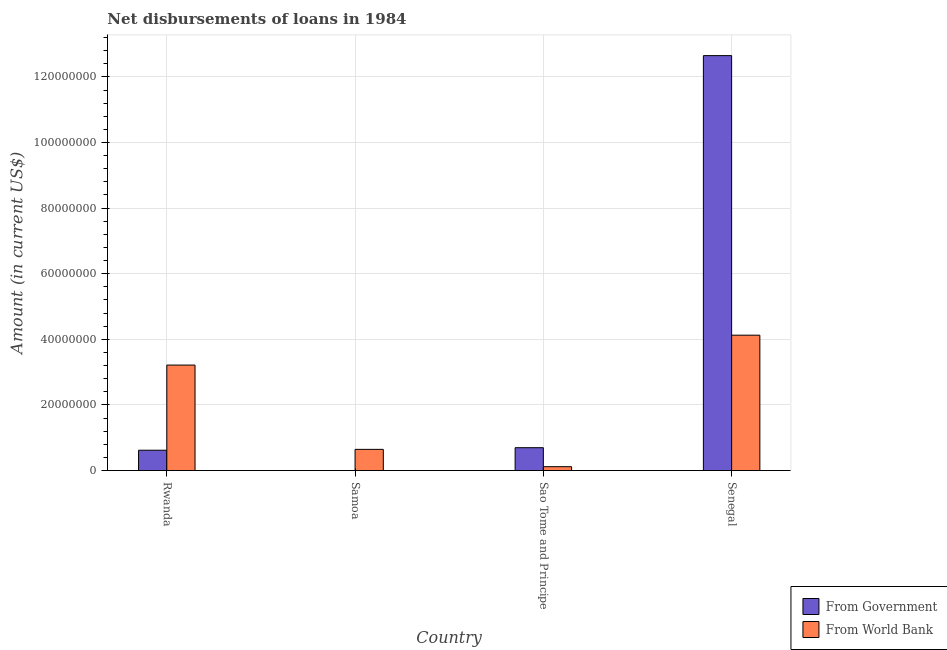How many different coloured bars are there?
Your answer should be compact. 2. Are the number of bars per tick equal to the number of legend labels?
Provide a short and direct response. No. How many bars are there on the 3rd tick from the left?
Make the answer very short. 2. What is the label of the 1st group of bars from the left?
Provide a short and direct response. Rwanda. What is the net disbursements of loan from government in Rwanda?
Provide a short and direct response. 6.20e+06. Across all countries, what is the maximum net disbursements of loan from government?
Give a very brief answer. 1.26e+08. In which country was the net disbursements of loan from government maximum?
Ensure brevity in your answer.  Senegal. What is the total net disbursements of loan from world bank in the graph?
Your response must be concise. 8.11e+07. What is the difference between the net disbursements of loan from government in Rwanda and that in Senegal?
Your answer should be very brief. -1.20e+08. What is the difference between the net disbursements of loan from government in Samoa and the net disbursements of loan from world bank in Rwanda?
Your response must be concise. -3.22e+07. What is the average net disbursements of loan from world bank per country?
Make the answer very short. 2.03e+07. What is the difference between the net disbursements of loan from government and net disbursements of loan from world bank in Rwanda?
Offer a terse response. -2.60e+07. In how many countries, is the net disbursements of loan from government greater than 108000000 US$?
Your answer should be compact. 1. What is the ratio of the net disbursements of loan from government in Rwanda to that in Sao Tome and Principe?
Your answer should be compact. 0.89. What is the difference between the highest and the second highest net disbursements of loan from world bank?
Provide a succinct answer. 9.11e+06. What is the difference between the highest and the lowest net disbursements of loan from world bank?
Offer a terse response. 4.01e+07. In how many countries, is the net disbursements of loan from world bank greater than the average net disbursements of loan from world bank taken over all countries?
Keep it short and to the point. 2. Is the sum of the net disbursements of loan from world bank in Rwanda and Senegal greater than the maximum net disbursements of loan from government across all countries?
Your response must be concise. No. What is the difference between two consecutive major ticks on the Y-axis?
Provide a succinct answer. 2.00e+07. Are the values on the major ticks of Y-axis written in scientific E-notation?
Your answer should be very brief. No. Does the graph contain any zero values?
Make the answer very short. Yes. Does the graph contain grids?
Keep it short and to the point. Yes. How are the legend labels stacked?
Your response must be concise. Vertical. What is the title of the graph?
Offer a very short reply. Net disbursements of loans in 1984. What is the label or title of the X-axis?
Your response must be concise. Country. What is the Amount (in current US$) of From Government in Rwanda?
Your response must be concise. 6.20e+06. What is the Amount (in current US$) in From World Bank in Rwanda?
Provide a short and direct response. 3.22e+07. What is the Amount (in current US$) in From Government in Samoa?
Provide a short and direct response. 0. What is the Amount (in current US$) of From World Bank in Samoa?
Give a very brief answer. 6.46e+06. What is the Amount (in current US$) of From Government in Sao Tome and Principe?
Offer a terse response. 6.97e+06. What is the Amount (in current US$) in From World Bank in Sao Tome and Principe?
Provide a short and direct response. 1.19e+06. What is the Amount (in current US$) of From Government in Senegal?
Provide a short and direct response. 1.26e+08. What is the Amount (in current US$) of From World Bank in Senegal?
Provide a short and direct response. 4.13e+07. Across all countries, what is the maximum Amount (in current US$) in From Government?
Your response must be concise. 1.26e+08. Across all countries, what is the maximum Amount (in current US$) of From World Bank?
Ensure brevity in your answer.  4.13e+07. Across all countries, what is the minimum Amount (in current US$) in From World Bank?
Give a very brief answer. 1.19e+06. What is the total Amount (in current US$) of From Government in the graph?
Your response must be concise. 1.40e+08. What is the total Amount (in current US$) in From World Bank in the graph?
Offer a terse response. 8.11e+07. What is the difference between the Amount (in current US$) in From World Bank in Rwanda and that in Samoa?
Ensure brevity in your answer.  2.57e+07. What is the difference between the Amount (in current US$) of From Government in Rwanda and that in Sao Tome and Principe?
Keep it short and to the point. -7.71e+05. What is the difference between the Amount (in current US$) in From World Bank in Rwanda and that in Sao Tome and Principe?
Your answer should be compact. 3.10e+07. What is the difference between the Amount (in current US$) of From Government in Rwanda and that in Senegal?
Make the answer very short. -1.20e+08. What is the difference between the Amount (in current US$) of From World Bank in Rwanda and that in Senegal?
Provide a short and direct response. -9.11e+06. What is the difference between the Amount (in current US$) of From World Bank in Samoa and that in Sao Tome and Principe?
Make the answer very short. 5.28e+06. What is the difference between the Amount (in current US$) of From World Bank in Samoa and that in Senegal?
Keep it short and to the point. -3.48e+07. What is the difference between the Amount (in current US$) in From Government in Sao Tome and Principe and that in Senegal?
Your answer should be compact. -1.20e+08. What is the difference between the Amount (in current US$) in From World Bank in Sao Tome and Principe and that in Senegal?
Your answer should be very brief. -4.01e+07. What is the difference between the Amount (in current US$) of From Government in Rwanda and the Amount (in current US$) of From World Bank in Samoa?
Offer a terse response. -2.62e+05. What is the difference between the Amount (in current US$) in From Government in Rwanda and the Amount (in current US$) in From World Bank in Sao Tome and Principe?
Make the answer very short. 5.01e+06. What is the difference between the Amount (in current US$) in From Government in Rwanda and the Amount (in current US$) in From World Bank in Senegal?
Your answer should be compact. -3.51e+07. What is the difference between the Amount (in current US$) in From Government in Sao Tome and Principe and the Amount (in current US$) in From World Bank in Senegal?
Your answer should be compact. -3.43e+07. What is the average Amount (in current US$) of From Government per country?
Offer a very short reply. 3.49e+07. What is the average Amount (in current US$) in From World Bank per country?
Your response must be concise. 2.03e+07. What is the difference between the Amount (in current US$) in From Government and Amount (in current US$) in From World Bank in Rwanda?
Your answer should be compact. -2.60e+07. What is the difference between the Amount (in current US$) in From Government and Amount (in current US$) in From World Bank in Sao Tome and Principe?
Keep it short and to the point. 5.78e+06. What is the difference between the Amount (in current US$) of From Government and Amount (in current US$) of From World Bank in Senegal?
Offer a very short reply. 8.52e+07. What is the ratio of the Amount (in current US$) in From World Bank in Rwanda to that in Samoa?
Provide a short and direct response. 4.97. What is the ratio of the Amount (in current US$) of From Government in Rwanda to that in Sao Tome and Principe?
Ensure brevity in your answer.  0.89. What is the ratio of the Amount (in current US$) of From World Bank in Rwanda to that in Sao Tome and Principe?
Offer a very short reply. 27.07. What is the ratio of the Amount (in current US$) of From Government in Rwanda to that in Senegal?
Give a very brief answer. 0.05. What is the ratio of the Amount (in current US$) of From World Bank in Rwanda to that in Senegal?
Your answer should be compact. 0.78. What is the ratio of the Amount (in current US$) in From World Bank in Samoa to that in Sao Tome and Principe?
Your answer should be compact. 5.44. What is the ratio of the Amount (in current US$) in From World Bank in Samoa to that in Senegal?
Ensure brevity in your answer.  0.16. What is the ratio of the Amount (in current US$) of From Government in Sao Tome and Principe to that in Senegal?
Make the answer very short. 0.06. What is the ratio of the Amount (in current US$) of From World Bank in Sao Tome and Principe to that in Senegal?
Your response must be concise. 0.03. What is the difference between the highest and the second highest Amount (in current US$) in From Government?
Provide a succinct answer. 1.20e+08. What is the difference between the highest and the second highest Amount (in current US$) of From World Bank?
Provide a succinct answer. 9.11e+06. What is the difference between the highest and the lowest Amount (in current US$) of From Government?
Offer a terse response. 1.26e+08. What is the difference between the highest and the lowest Amount (in current US$) in From World Bank?
Provide a short and direct response. 4.01e+07. 